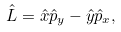Convert formula to latex. <formula><loc_0><loc_0><loc_500><loc_500>\hat { L } = \hat { x } \hat { p } _ { y } - \hat { y } \hat { p } _ { x } ,</formula> 